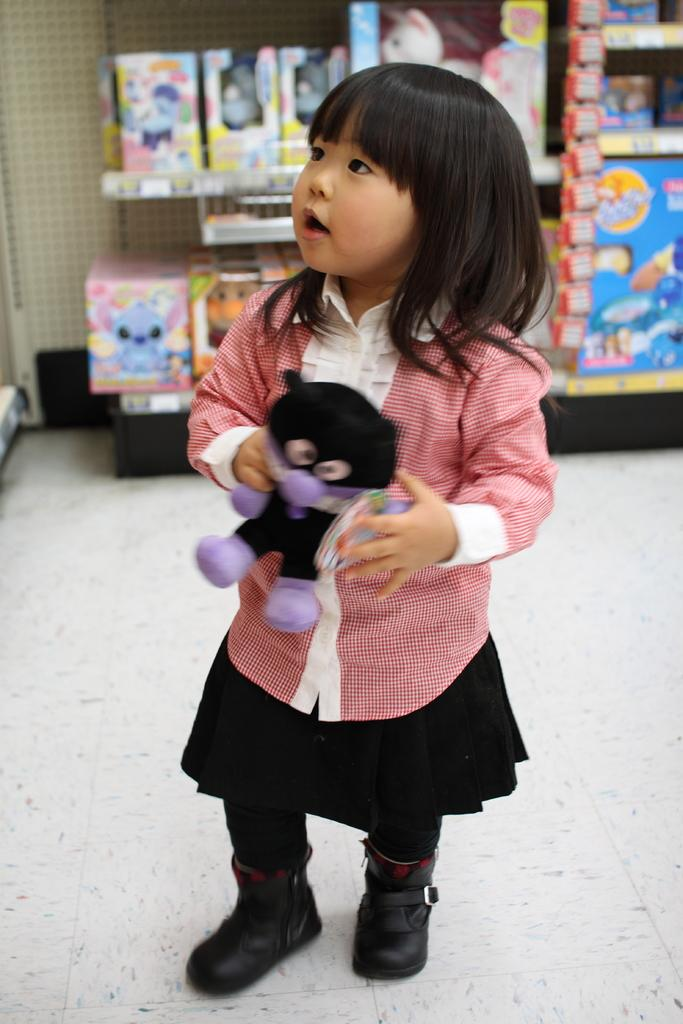Who is the main subject in the image? There is a girl in the image. What is the girl holding in the image? The girl is holding a toy. Can you describe the background of the image? There are toys in boxes on shelves in the background of the image. What type of suit is the girl's father wearing in the image? There is no mention of a father or a suit in the image; it only features a girl holding a toy and toys in boxes on shelves in the background. 